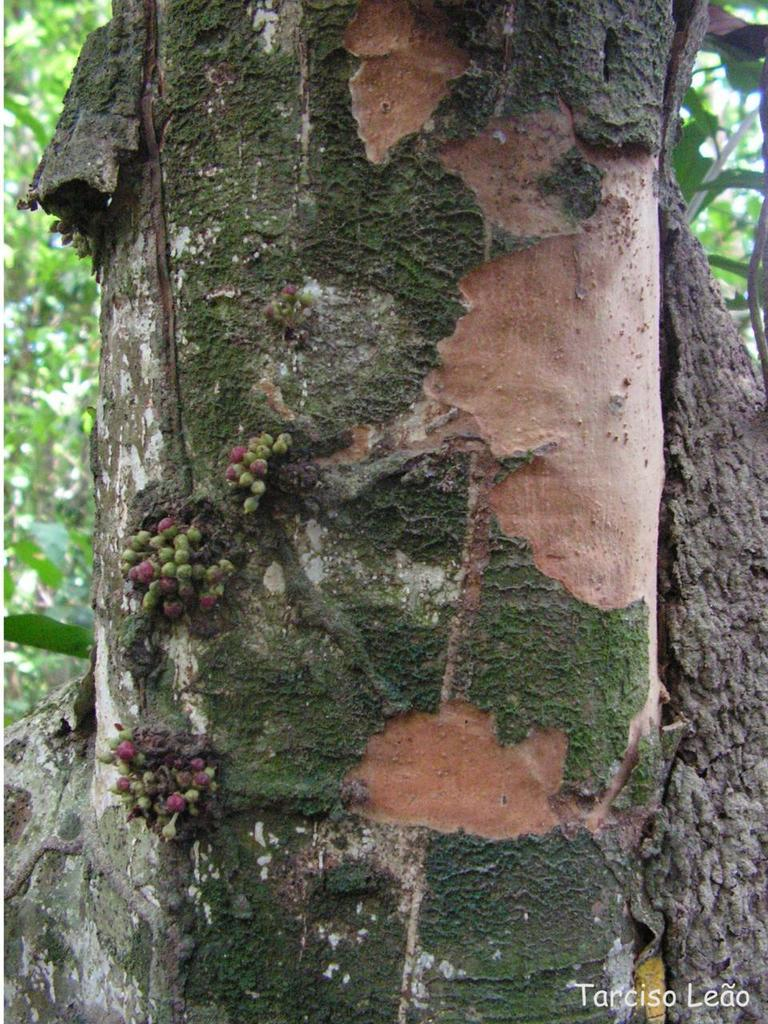What is on the tree trunk in the image? There are fruits on the tree trunk in the image. What can be seen in the background of the image? There are trees in the background of the image. Is there any additional information or branding on the image? Yes, there is a watermark on the image. What type of silk fabric is draped over the branches of the tree in the image? There is no silk fabric present in the image; it features fruits on the tree trunk and trees in the background. 